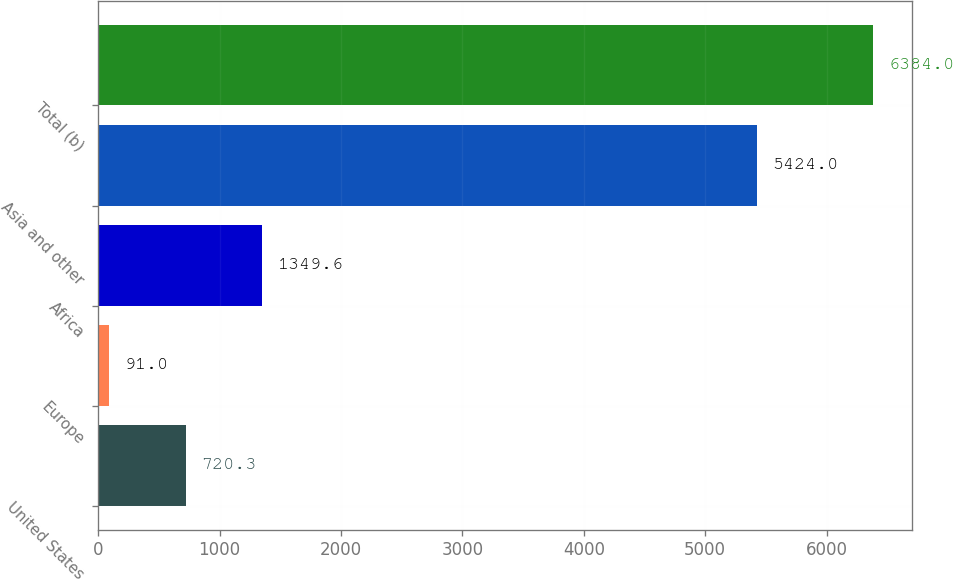Convert chart. <chart><loc_0><loc_0><loc_500><loc_500><bar_chart><fcel>United States<fcel>Europe<fcel>Africa<fcel>Asia and other<fcel>Total (b)<nl><fcel>720.3<fcel>91<fcel>1349.6<fcel>5424<fcel>6384<nl></chart> 